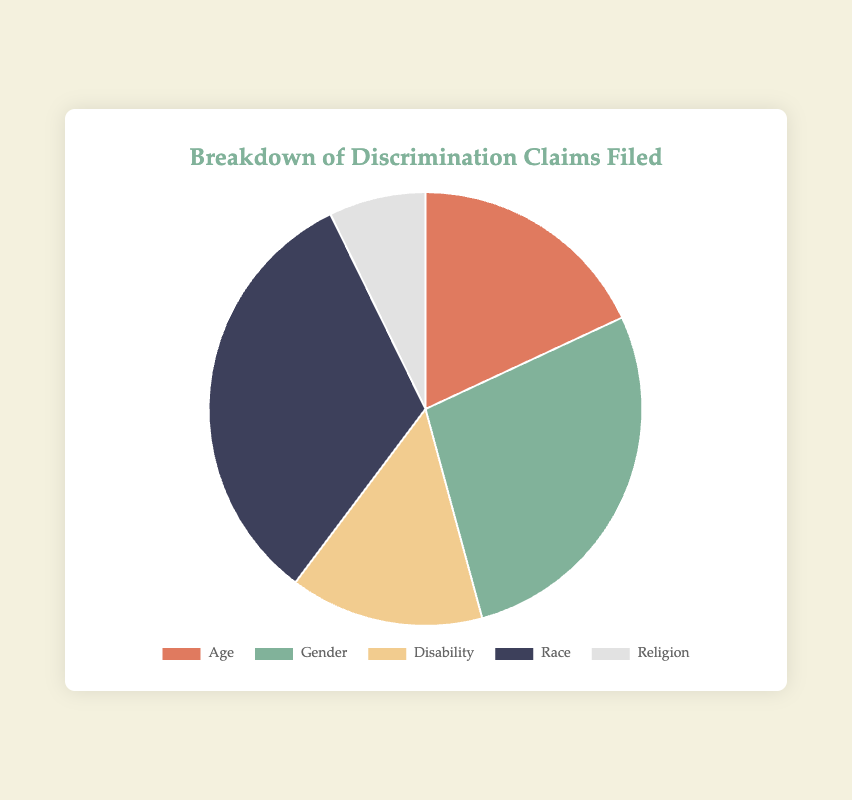Which category has the highest number of discrimination claims filed? By looking at the pie chart, we can identify the segment with the largest size. The "Race" category has the largest segment with 2700 claims.
Answer: Race Which category has the smallest number of discrimination claims filed? The smallest segment of the pie chart corresponds to the "Religious Discrimination" category with 600 claims.
Answer: Religion How many more claims were filed for gender discrimination compared to age discrimination? The claims for gender discrimination are 2300, and for age discrimination, they are 1500. Subtracting the two gives: 2300 - 1500 = 800
Answer: 800 What is the total number of discrimination claims filed? Adding the claims from all categories: 1500 (Age) + 2300 (Gender) + 1200 (Disability) + 2700 (Race) + 600 (Religion) = 8300
Answer: 8300 What percentage of the total claims are for disability discrimination? The number of disability discrimination claims is 1200. Total claims are 8300. The percentage is calculated as (1200 / 8300) * 100 = approximately 14.46%
Answer: ~14.5% Compare the number of race discrimination claims to gender discrimination claims. The number of race discrimination claims is 2700 and gender discrimination claims are 2300. Race discrimination claims are greater: 2700 > 2300
Answer: Race discrimination claims are greater What is the combined percentage of age and religious discrimination claims? First, find the total number of claims: 8300. Then add claims for age and religion: 1500 (Age) + 600 (Religion) = 2100. The combined percentage is (2100 / 8300) * 100 = approximately 25.3%
Answer: ~25.3% Which segments are visually represented by green and yellow colors? Examining the colors used in the chart, the green segment corresponds to "Gender" and the yellow segment corresponds to "Disability."
Answer: Gender and Disability Is the ratio of gender discrimination claims to disability discrimination claims greater than 2:1? The number of gender discrimination claims is 2300, and for disability discrimination, it is 1200. The ratio is 2300:1200, which simplifies to approximately 1.92:1. This is less than 2:1.
Answer: No 